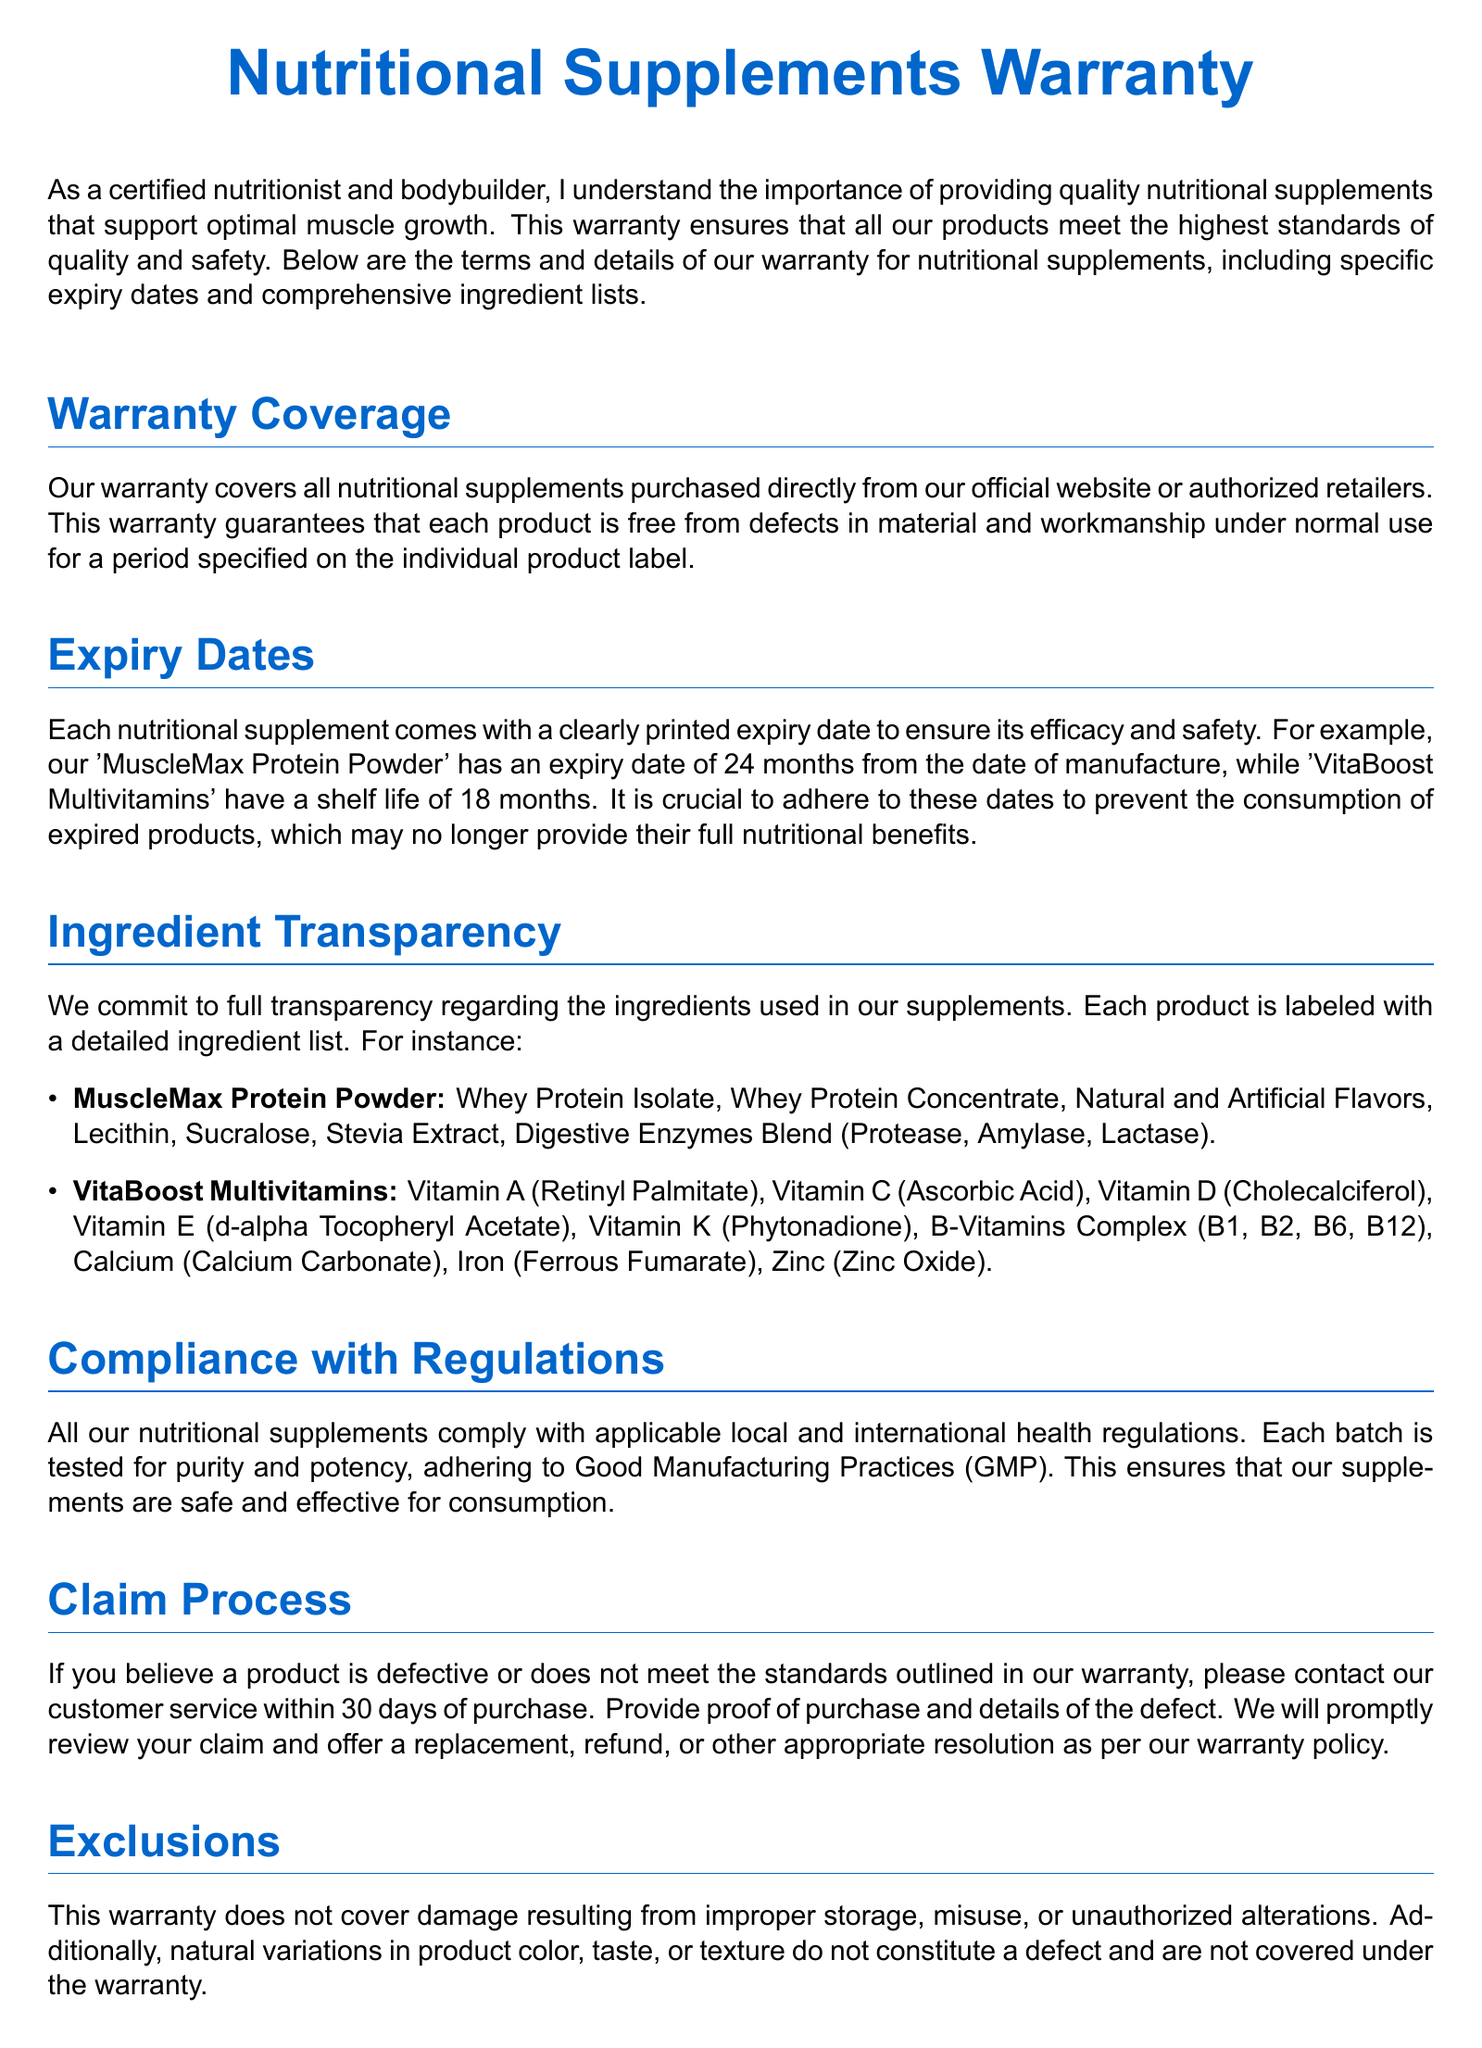What is the warranty coverage duration? The warranty covers nutritional supplements for a period specified on the individual product label.
Answer: Specified on the individual product label What is the expiry date for MuscleMax Protein Powder? The expiry date for MuscleMax Protein Powder is explicitly mentioned, which is 24 months from the date of manufacture.
Answer: 24 months What types of flavors are in MuscleMax Protein Powder? The document lists "Natural and Artificial Flavors" as part of the MuscleMax Protein Powder ingredient list.
Answer: Natural and Artificial Flavors How long is the shelf life of VitaBoost Multivitamins? The shelf life of VitaBoost Multivitamins is clearly stated in the document.
Answer: 18 months What should you do if you believe a product is defective? The document explains the process to follow if a product is suspected to be defective, which includes contacting customer service within 30 days of purchase.
Answer: Contact customer service within 30 days What are the exclusions of the warranty? The document specifies what is not covered under the warranty, such as damage from improper storage and natural variations.
Answer: Damage from improper storage How can consumers contact customer support? The document provides specific contact information for customer support for inquiries or claims related to the warranty.
Answer: support@nutrifit.com or (555) 123-4567 What practices do the supplements comply with? The document states that the nutritional supplements comply with Good Manufacturing Practices (GMP).
Answer: Good Manufacturing Practices (GMP) 